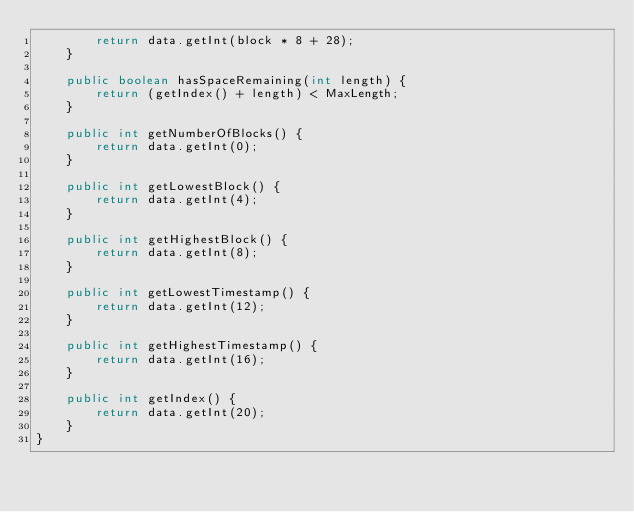Convert code to text. <code><loc_0><loc_0><loc_500><loc_500><_Java_>        return data.getInt(block * 8 + 28);
    }

    public boolean hasSpaceRemaining(int length) {
        return (getIndex() + length) < MaxLength;
    }

    public int getNumberOfBlocks() {
        return data.getInt(0);
    }

    public int getLowestBlock() {
        return data.getInt(4);
    }

    public int getHighestBlock() {
        return data.getInt(8);
    }

    public int getLowestTimestamp() {
        return data.getInt(12);
    }

    public int getHighestTimestamp() {
        return data.getInt(16);
    }

    public int getIndex() {
        return data.getInt(20);
    }
}
</code> 